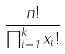Convert formula to latex. <formula><loc_0><loc_0><loc_500><loc_500>\frac { n ! } { \prod _ { i = 1 } ^ { k } x _ { i } ! }</formula> 